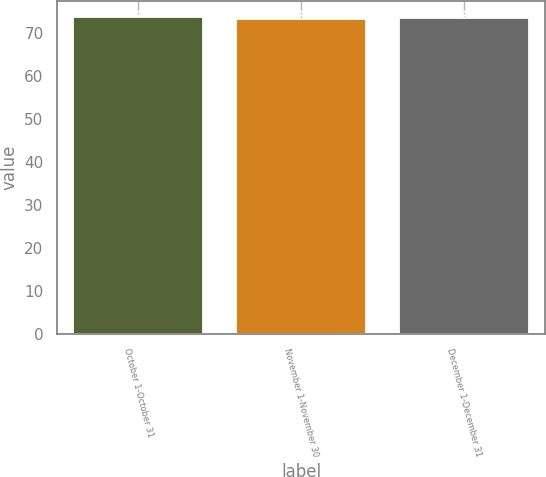<chart> <loc_0><loc_0><loc_500><loc_500><bar_chart><fcel>October 1-October 31<fcel>November 1-November 30<fcel>December 1-December 31<nl><fcel>73.64<fcel>73.26<fcel>73.4<nl></chart> 